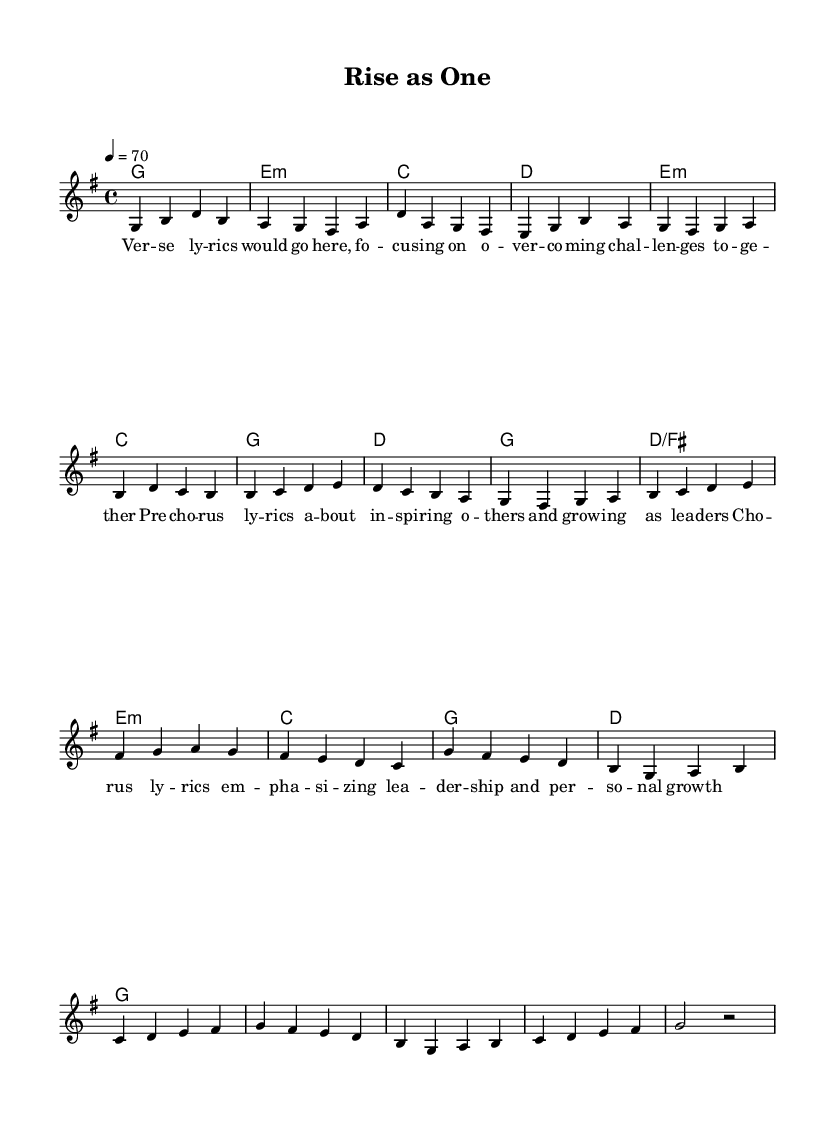What is the key signature of this music? The key signature is G major, which contains one sharp (F#). This can be determined by identifying the signature at the beginning of the score, noted specifically just before the clef.
Answer: G major What is the time signature of the piece? The time signature is 4/4, which is indicated at the beginning of the score. It shows that there are four beats in each measure, and each quarter note gets one beat.
Answer: 4/4 What is the tempo marking for this piece? The tempo marking is quarter note equals 70, which dictates the speed at which the piece should be played. This information appears after the time signature and indicates a moderate pace.
Answer: 70 How many sections are present in the music? The music consists of three sections as indicated by the structure: Verse, Pre-chorus, and Chorus. Each section has distinct lyrics and musical phrases and can be inferred from the lyrical organization within the score.
Answer: Three What type of lyrics does the pre-chorus section focus on? The pre-chorus lyrics emphasize inspiration and personal growth of others. This theme can be discerned by reading the lyrics in the specified section, which often sets up the main message of the song.
Answer: Inspiring What are the chord types used in the verse section? The verse section utilizes major and minor chords. Specifically, the chords identified are G major, E minor, C major, and D major, as presented in the harmonies beneath the melody.
Answer: Major and minor Which musical element in the chorus emphasizes leadership and personal growth? In the chorus, the repetition and phrasing of the lyrics highlight leadership and personal growth, making this section particularly impactful. The lyrics here are directly emphasizing the main theme of the song, which can be analyzed in the context of the chorus structure.
Answer: Repetition 